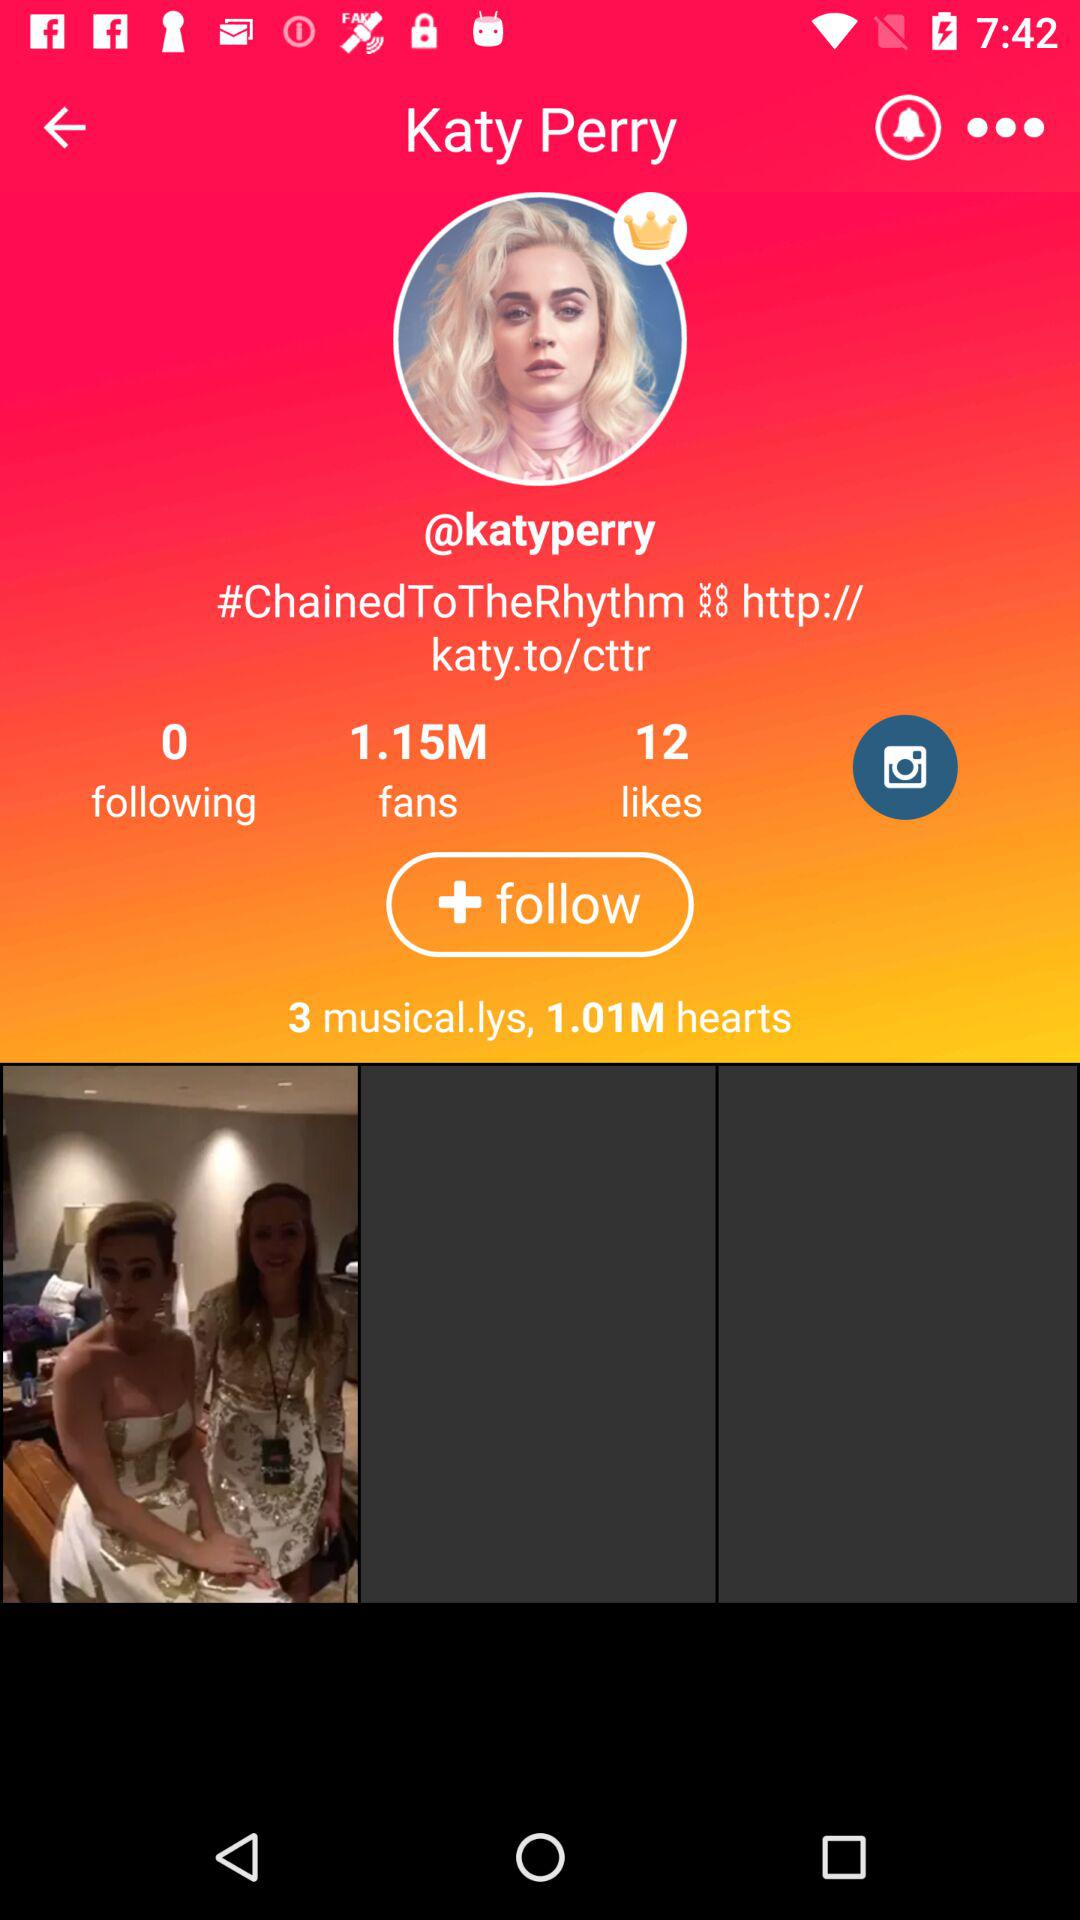How many people does "katyperry" follow? "katyperry" follows 0 people. 